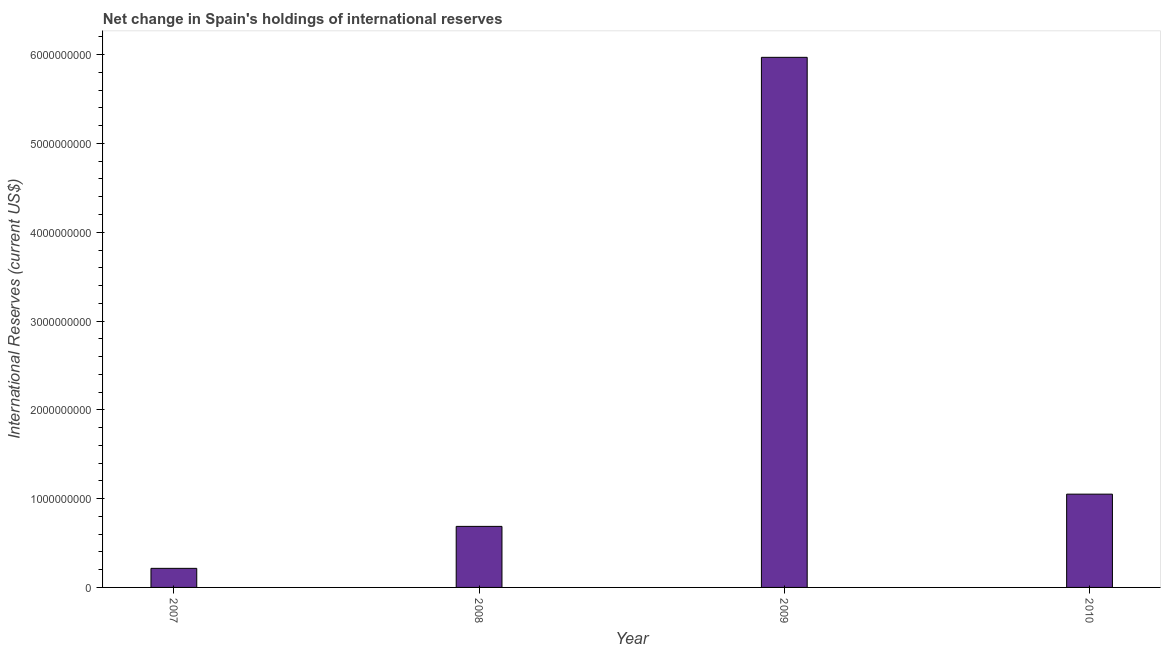Does the graph contain any zero values?
Your answer should be compact. No. What is the title of the graph?
Offer a terse response. Net change in Spain's holdings of international reserves. What is the label or title of the Y-axis?
Keep it short and to the point. International Reserves (current US$). What is the reserves and related items in 2007?
Your answer should be compact. 2.15e+08. Across all years, what is the maximum reserves and related items?
Your response must be concise. 5.97e+09. Across all years, what is the minimum reserves and related items?
Your answer should be compact. 2.15e+08. In which year was the reserves and related items maximum?
Offer a terse response. 2009. What is the sum of the reserves and related items?
Offer a terse response. 7.92e+09. What is the difference between the reserves and related items in 2009 and 2010?
Your response must be concise. 4.92e+09. What is the average reserves and related items per year?
Make the answer very short. 1.98e+09. What is the median reserves and related items?
Provide a succinct answer. 8.69e+08. In how many years, is the reserves and related items greater than 5000000000 US$?
Provide a short and direct response. 1. Do a majority of the years between 2008 and 2010 (inclusive) have reserves and related items greater than 4200000000 US$?
Your answer should be very brief. No. What is the ratio of the reserves and related items in 2007 to that in 2009?
Make the answer very short. 0.04. Is the difference between the reserves and related items in 2007 and 2009 greater than the difference between any two years?
Make the answer very short. Yes. What is the difference between the highest and the second highest reserves and related items?
Provide a short and direct response. 4.92e+09. What is the difference between the highest and the lowest reserves and related items?
Your answer should be very brief. 5.76e+09. How many bars are there?
Your answer should be very brief. 4. Are all the bars in the graph horizontal?
Offer a very short reply. No. How many years are there in the graph?
Give a very brief answer. 4. Are the values on the major ticks of Y-axis written in scientific E-notation?
Ensure brevity in your answer.  No. What is the International Reserves (current US$) in 2007?
Offer a terse response. 2.15e+08. What is the International Reserves (current US$) in 2008?
Offer a terse response. 6.88e+08. What is the International Reserves (current US$) in 2009?
Offer a very short reply. 5.97e+09. What is the International Reserves (current US$) of 2010?
Your answer should be compact. 1.05e+09. What is the difference between the International Reserves (current US$) in 2007 and 2008?
Give a very brief answer. -4.73e+08. What is the difference between the International Reserves (current US$) in 2007 and 2009?
Your answer should be very brief. -5.76e+09. What is the difference between the International Reserves (current US$) in 2007 and 2010?
Ensure brevity in your answer.  -8.36e+08. What is the difference between the International Reserves (current US$) in 2008 and 2009?
Provide a succinct answer. -5.28e+09. What is the difference between the International Reserves (current US$) in 2008 and 2010?
Provide a short and direct response. -3.63e+08. What is the difference between the International Reserves (current US$) in 2009 and 2010?
Your response must be concise. 4.92e+09. What is the ratio of the International Reserves (current US$) in 2007 to that in 2008?
Offer a terse response. 0.31. What is the ratio of the International Reserves (current US$) in 2007 to that in 2009?
Provide a short and direct response. 0.04. What is the ratio of the International Reserves (current US$) in 2007 to that in 2010?
Offer a terse response. 0.2. What is the ratio of the International Reserves (current US$) in 2008 to that in 2009?
Make the answer very short. 0.12. What is the ratio of the International Reserves (current US$) in 2008 to that in 2010?
Offer a very short reply. 0.65. What is the ratio of the International Reserves (current US$) in 2009 to that in 2010?
Your response must be concise. 5.68. 